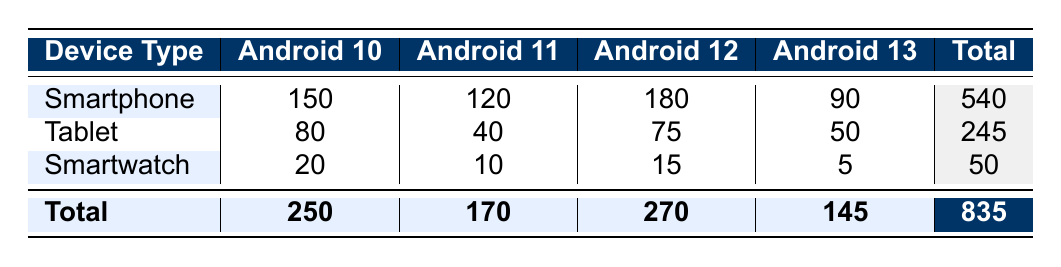What is the total crash count for smartphones? To find the total crash count for smartphones, we need to sum the crash counts across all operating system versions for this device type. The crash counts are 150 (Android 10) + 120 (Android 11) + 180 (Android 12) + 90 (Android 13) = 540.
Answer: 540 Which operating system version had the highest crash count for tablets? Looking at the table, the crash counts for tablets are: 80 (Android 10), 40 (Android 11), 75 (Android 12), and 50 (Android 13). The highest count is 80 for Android 10.
Answer: Android 10 Is the average crash count for smartwatches higher than that for tablets? First, calculate the average crash count for each device type. For smartwatches: (20 + 10 + 15 + 5) / 4 = 50 / 4 = 12.5. For tablets: (80 + 40 + 75 + 50) / 4 = 245 / 4 = 61.25. Since 12.5 is less than 61.25, the average for smartwatches is not higher than for tablets.
Answer: No How many crashes occurred on Android 11 across all device types combined? To find this, we add the crash counts for Android 11 from all device types: 120 (smartphone) + 40 (tablet) + 10 (smartwatch) = 170.
Answer: 170 What percentage of crashes for tablets occurred on Android 12? The crash count for tablets on Android 12 is 75, and the total crash count for tablets is 245. To find the percentage, we calculate (75 / 245) * 100 = 30.61%.
Answer: 30.61% Is it true that the number of crashes for smartphones decreased from Android 12 to Android 13? The crash count for Android 12 is 180 and for Android 13 is 90. Since 90 is less than 180, it is true that the number of crashes decreased.
Answer: Yes Which device type had the lowest total crash count? The total crash counts for each device type are: smartphones = 540, tablets = 245, smartwatches = 50. The lowest is 50, which is for smartwatches.
Answer: Smartwatch What is the total number of crashes for Android 10 devices? The total crash counts for Android 10 are: 150 (smartphone) + 80 (tablet) + 20 (smartwatch) = 250.
Answer: 250 What is the difference in crash counts between Android 12 and Android 13 for all devices combined? The total crash counts are 270 for Android 12 and 145 for Android 13. The difference is 270 - 145 = 125.
Answer: 125 